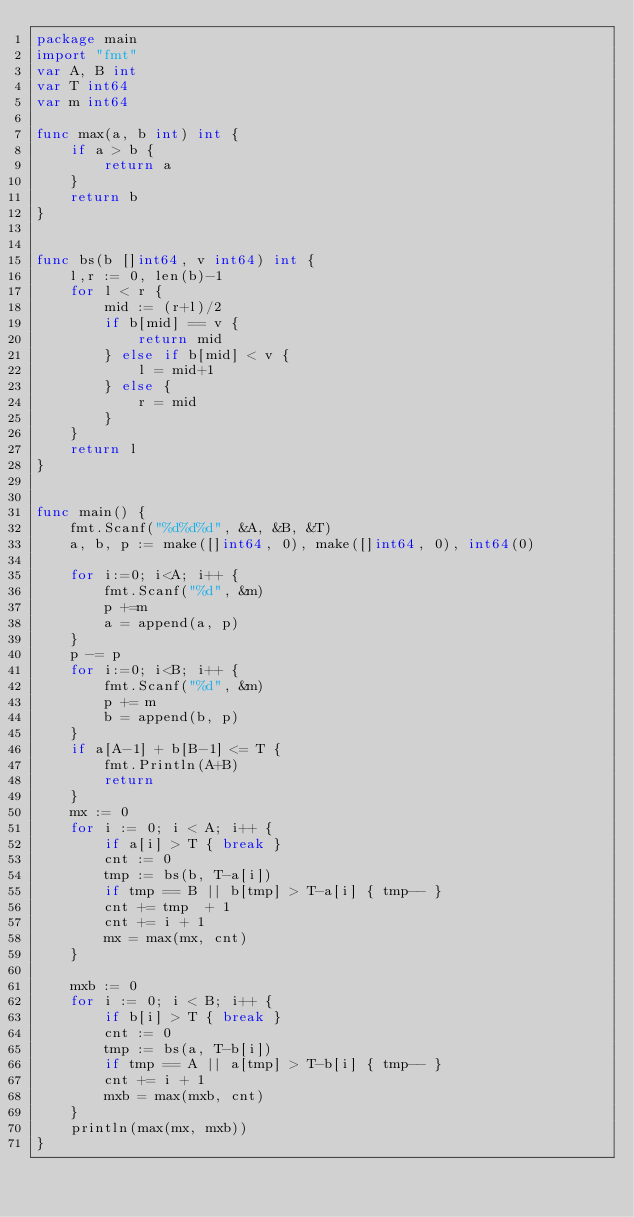<code> <loc_0><loc_0><loc_500><loc_500><_Go_>package main
import "fmt"
var A, B int
var T int64
var m int64

func max(a, b int) int {
	if a > b {
		return a
	}
	return b
}


func bs(b []int64, v int64) int {
	l,r := 0, len(b)-1
	for l < r {
      	mid := (r+l)/2
		if b[mid] == v {
			return mid
		} else if b[mid] < v {
			l = mid+1
		} else {
			r = mid
		}
	}
	return l
}


func main() {
	fmt.Scanf("%d%d%d", &A, &B, &T)
	a, b, p := make([]int64, 0), make([]int64, 0), int64(0)

	for i:=0; i<A; i++ {
		fmt.Scanf("%d", &m)
		p +=m
		a = append(a, p)
	}
	p -= p
	for i:=0; i<B; i++ {
		fmt.Scanf("%d", &m)
		p += m
		b = append(b, p)
	}
	if a[A-1] + b[B-1] <= T {
		fmt.Println(A+B)
		return
	}
	mx := 0
	for i := 0; i < A; i++ {
		if a[i] > T { break }
		cnt := 0
		tmp := bs(b, T-a[i])
		if tmp == B || b[tmp] > T-a[i] { tmp-- }
		cnt += tmp  + 1
		cnt += i + 1
		mx = max(mx, cnt)
	}

	mxb := 0
	for i := 0; i < B; i++ {
		if b[i] > T { break }
		cnt := 0
		tmp := bs(a, T-b[i])
		if tmp == A || a[tmp] > T-b[i] { tmp-- }
		cnt += i + 1
		mxb = max(mxb, cnt)
	}
	println(max(mx, mxb))
}
</code> 